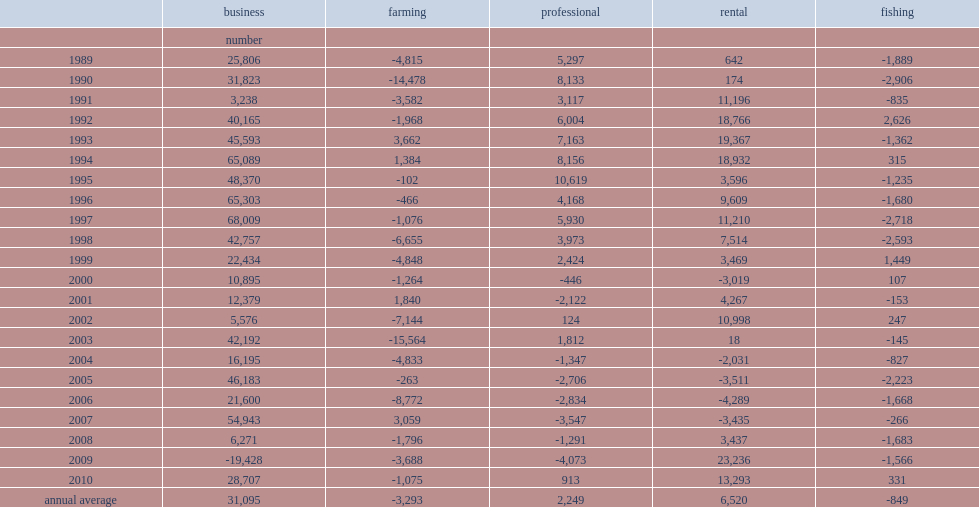How many self-employed individuals were on average in the business category each year between 1989 and 2010? 31095.0. How many unincorporated self-employed individuals the rental sector had between 1989 and 2010? 6520.0. How many unincorporated self-employed individuals the professional sector had over each year? 2249.0. How many the self-employed in the farming sector fell each year on average during 1989-2010? 3293. How many the self-employed in the fishing sector fell each year on average during 1989-2010? 849. 